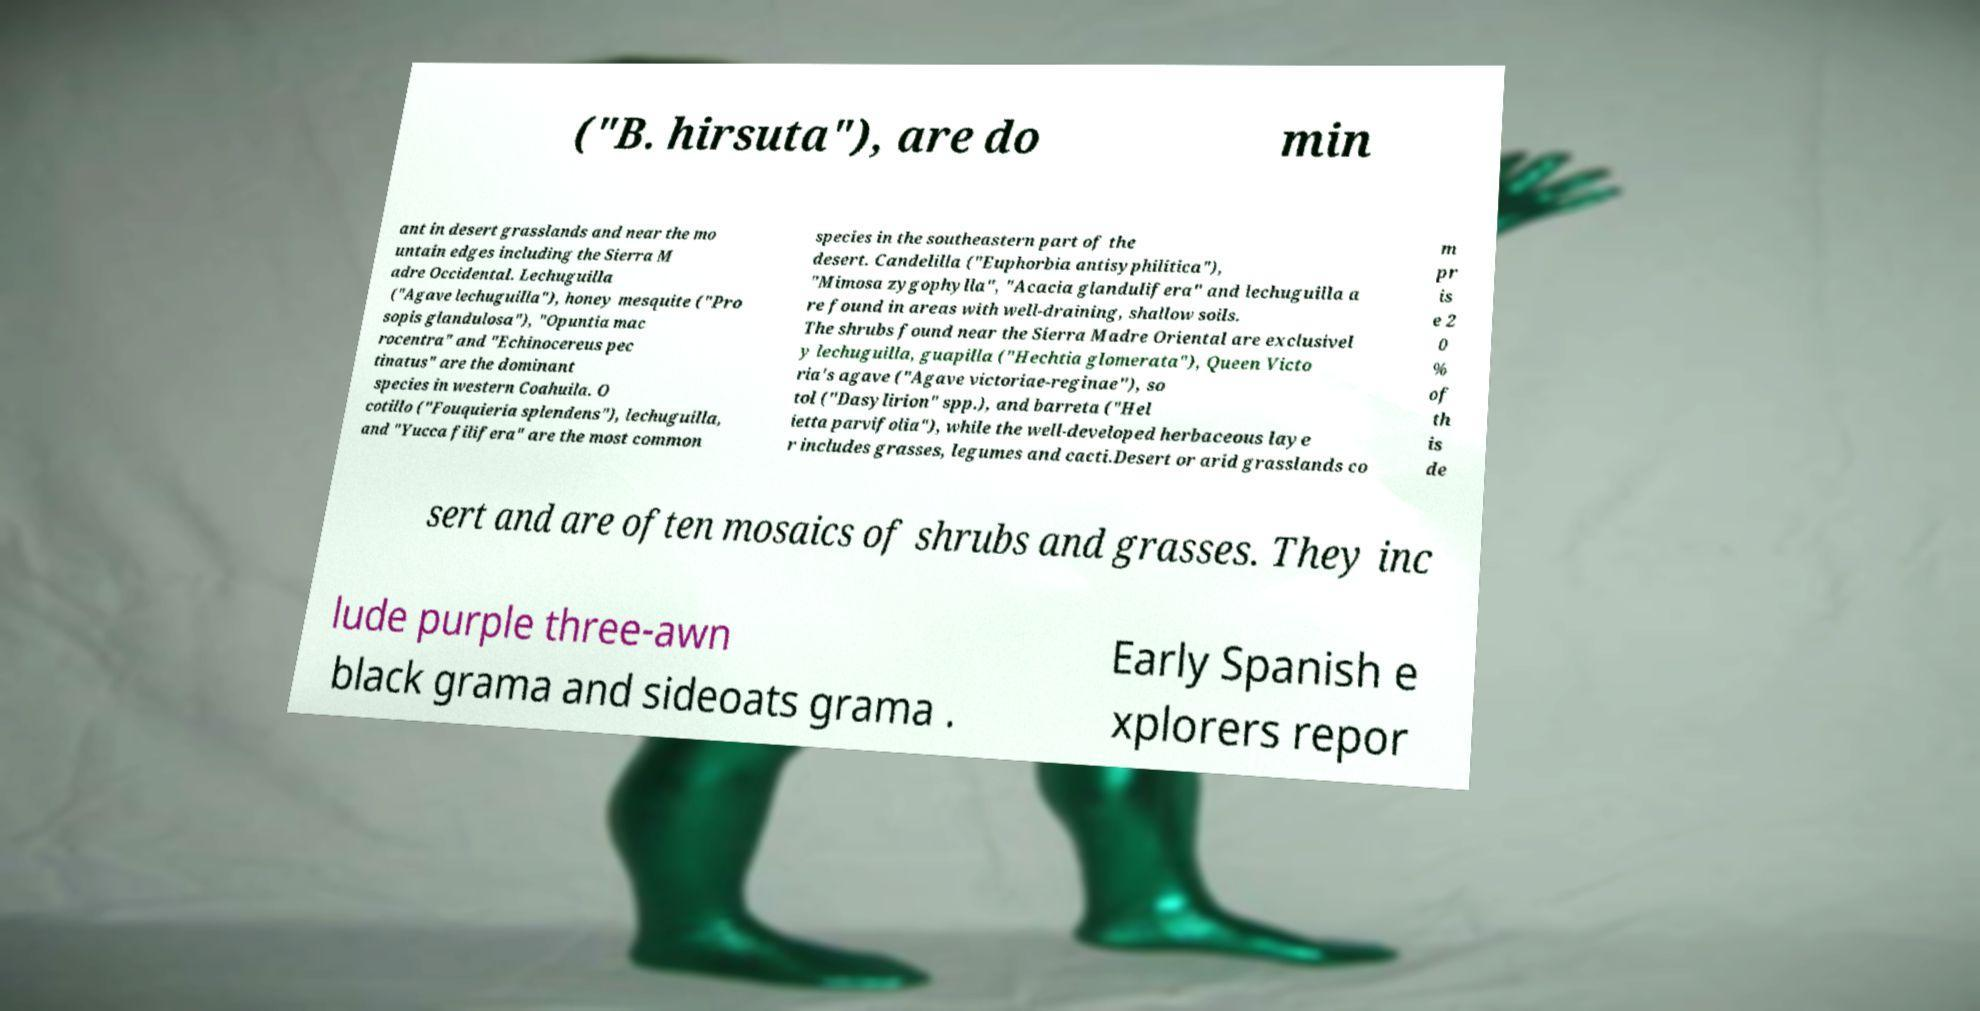There's text embedded in this image that I need extracted. Can you transcribe it verbatim? ("B. hirsuta"), are do min ant in desert grasslands and near the mo untain edges including the Sierra M adre Occidental. Lechuguilla ("Agave lechuguilla"), honey mesquite ("Pro sopis glandulosa"), "Opuntia mac rocentra" and "Echinocereus pec tinatus" are the dominant species in western Coahuila. O cotillo ("Fouquieria splendens"), lechuguilla, and "Yucca filifera" are the most common species in the southeastern part of the desert. Candelilla ("Euphorbia antisyphilitica"), "Mimosa zygophylla", "Acacia glandulifera" and lechuguilla a re found in areas with well-draining, shallow soils. The shrubs found near the Sierra Madre Oriental are exclusivel y lechuguilla, guapilla ("Hechtia glomerata"), Queen Victo ria's agave ("Agave victoriae-reginae"), so tol ("Dasylirion" spp.), and barreta ("Hel ietta parvifolia"), while the well-developed herbaceous laye r includes grasses, legumes and cacti.Desert or arid grasslands co m pr is e 2 0 % of th is de sert and are often mosaics of shrubs and grasses. They inc lude purple three-awn black grama and sideoats grama . Early Spanish e xplorers repor 